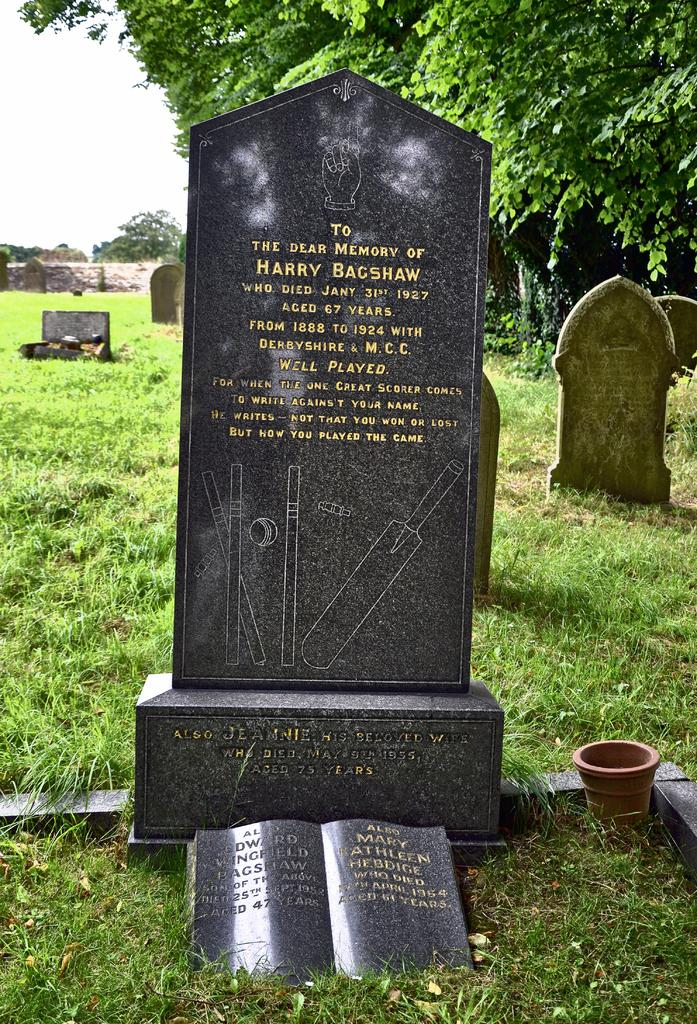What type of location is depicted in the image? There is a graveyard in the image. What type of vegetation can be seen in the image? There is grass visible in the image. What object can be seen in the image besides the graveyard? There is a pot in the image. What architectural feature is visible in the background of the image? There is a wall in the background of the image. What type of natural elements are visible in the background of the image? There are trees in the background of the image. What is visible at the top of the image? The sky is visible at the top of the image. Where is the toy located in the image? There is no toy present in the image. What type of board is visible in the image? There is no board present in the image. 